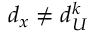Convert formula to latex. <formula><loc_0><loc_0><loc_500><loc_500>d _ { x } \neq d _ { U } ^ { k }</formula> 